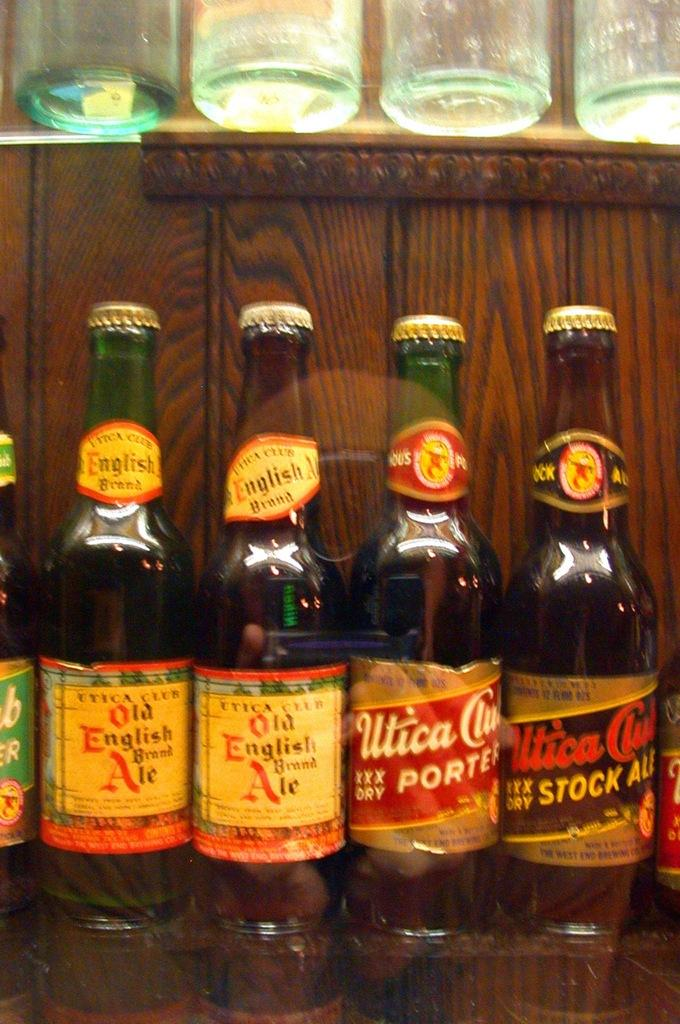<image>
Write a terse but informative summary of the picture. Two bottles of Old English brand Ale next to other bottles of beer 